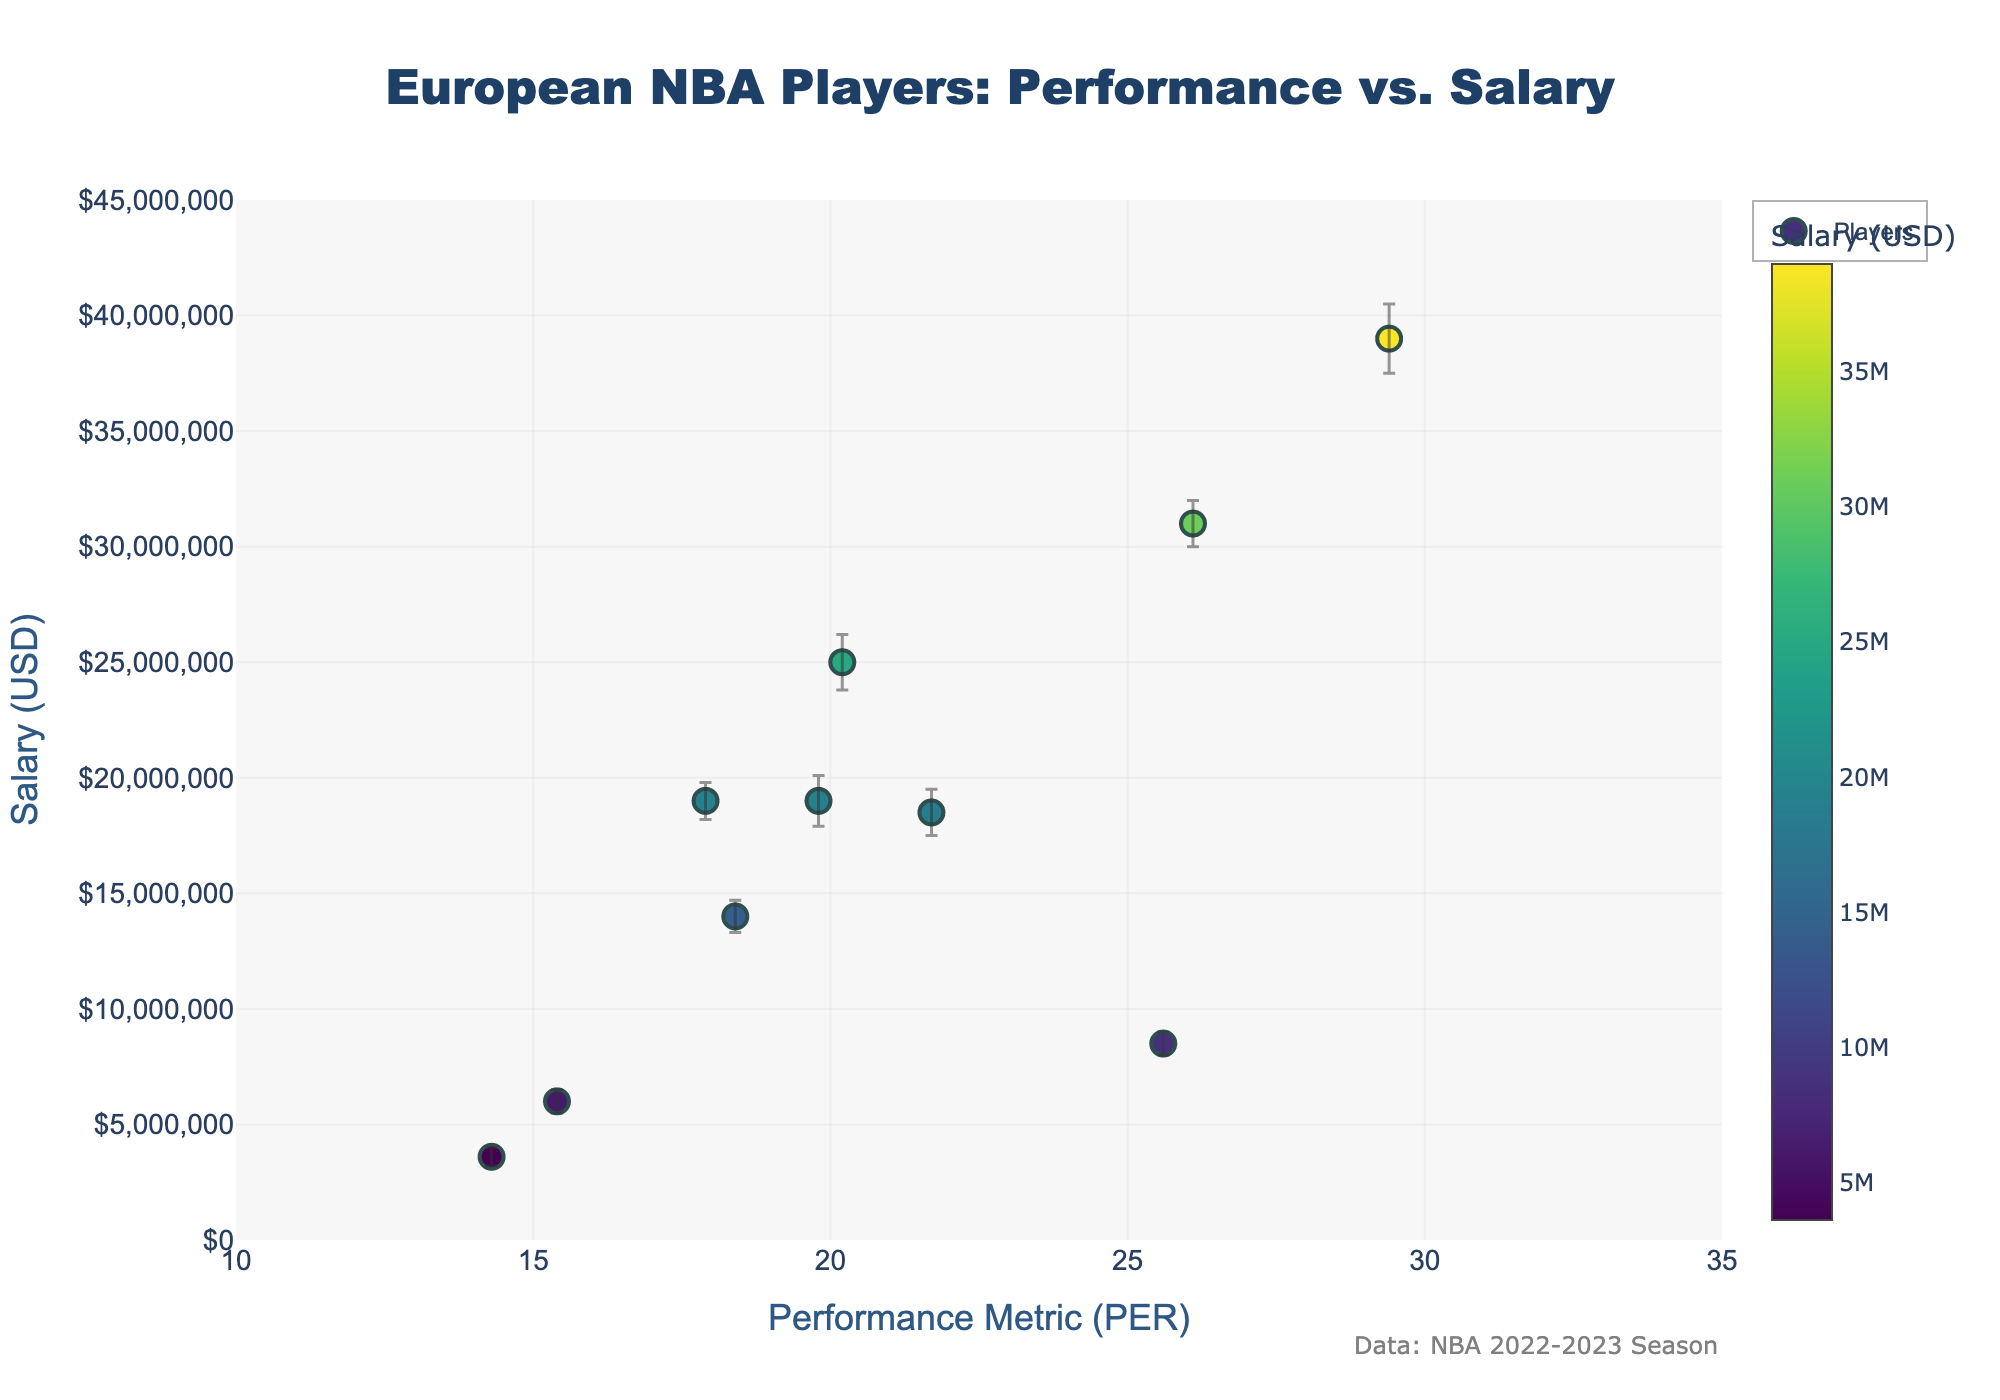What's the title of the figure? The title of the figure is located at the top and often describes the main topic of the plot. The title here reads "European NBA Players: Performance vs. Salary".
Answer: European NBA Players: Performance vs. Salary What's the y-axis representing? The y-axis represents the salaries of the players in USD. It is labeled as "Salary (USD)".
Answer: Salary (USD) What's the x-axis range? The x-axis range can be determined by looking at the values along the axis. They vary from about 10 to 35.
Answer: 10 to 35 Which player's salary has the smallest error bar? To determine the player with the smallest salary error bar, look for the shortest vertical line among the error bars. A short length is seen for Danilo Gallinari.
Answer: Danilo Gallinari What is the highest salary among the players, and who receives it? The highest salary can be identified by finding the highest point on the y-axis. The highest point is approximately $39,000,000, belonging to Giannis Antetokounmpo.
Answer: $39,000,000, Giannis Antetokounmpo Which player has the lowest performance metric (PER) and what is their salary? The lowest performance metric (PER) can be found by locating the leftmost point on the x-axis. Danilo Gallinari has the lowest PER and a salary of $6,000,000.
Answer: Danilo Gallinari, $6,000,000 Compare the salaries of Luka Dončić and Kristaps Porziņģis. Who earns more? Luka Dončić's salary is represented by a point higher on the y-axis compared to Kristaps Porziņģis. Luka Dončić earns $8,500,000, which is more than Kristaps Porziņģis's $19,000,000.
Answer: Kristaps Porziņģis What's the average performance metric (PER) of players with salaries above $30,000,000? First, identify the players with salaries above $30,000,000: Giannis Antetokounmpo ($39,000,000) and Nikola Jokić ($31,000,000). Then, calculate the average of their PERs: (29.4 + 26.1) / 2 = 27.75.
Answer: 27.75 Who has a higher salary: Rudy Gobert or Domantas Sabonis? Locate Rudy Gobert and Domantas Sabonis on the y-axis and compare their positions. Rudy Gobert ($25,000,000) earns more than Domantas Sabonis ($18,500,000).
Answer: Rudy Gobert 